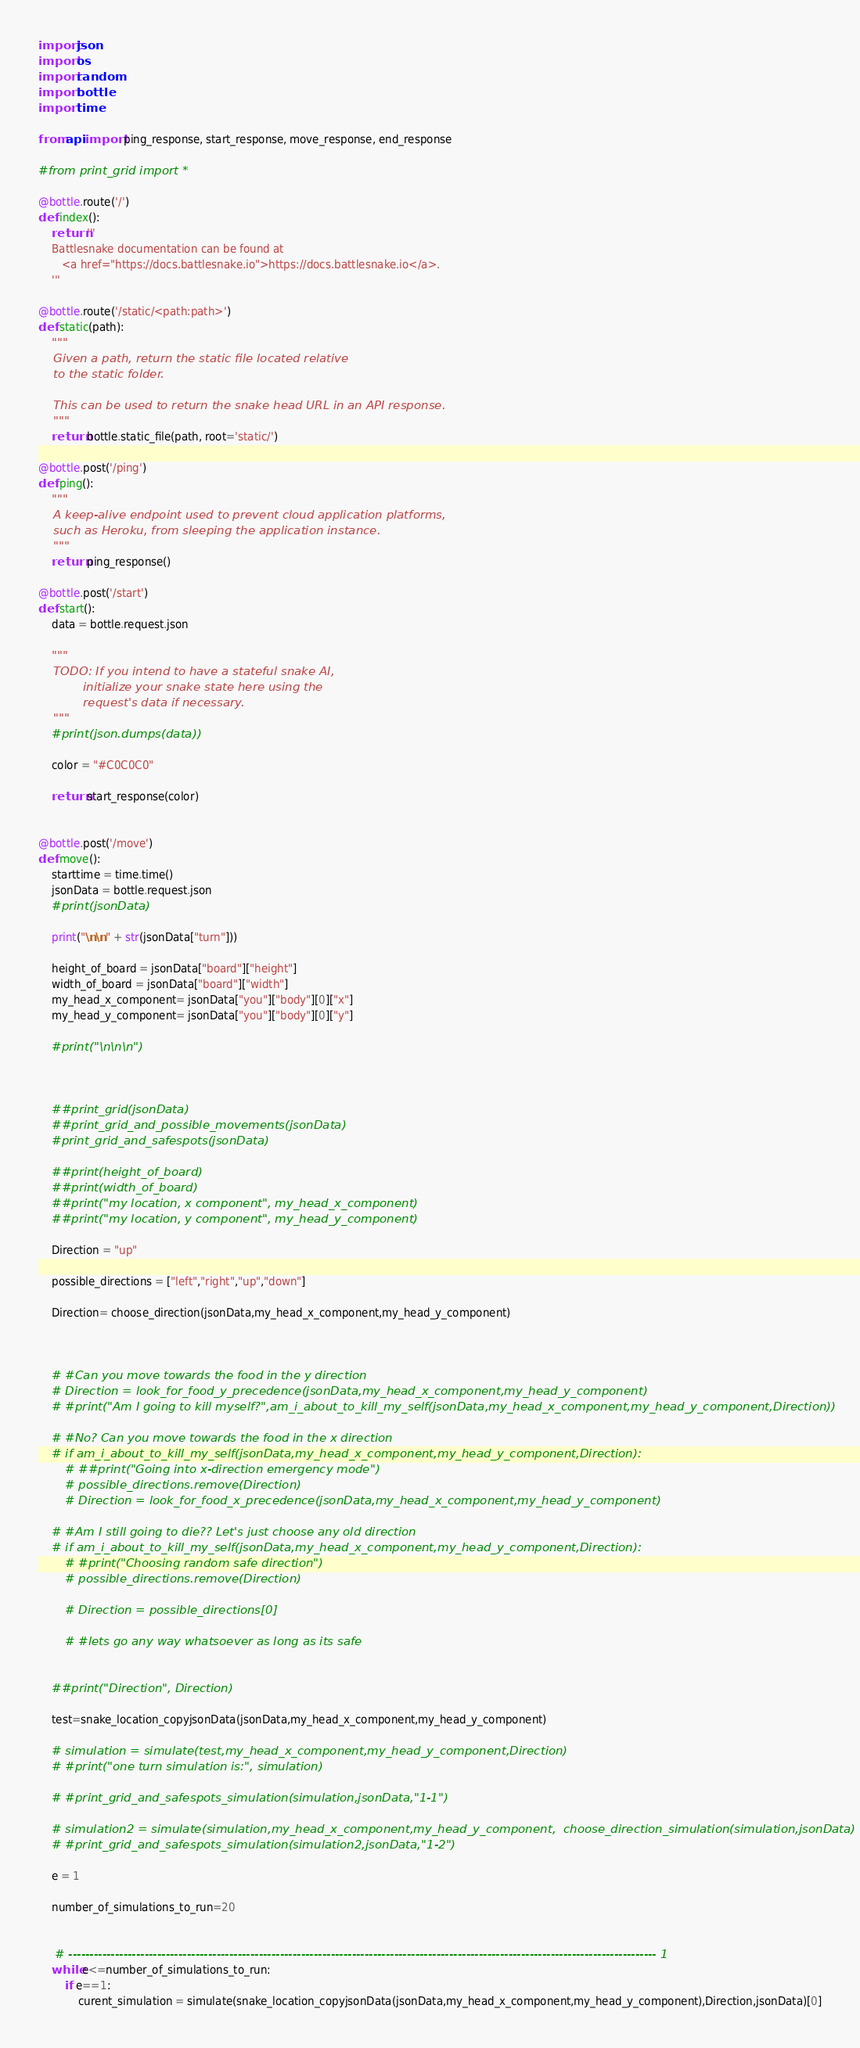<code> <loc_0><loc_0><loc_500><loc_500><_Python_>import json
import os
import random
import bottle
import time

from api import ping_response, start_response, move_response, end_response

#from print_grid import *

@bottle.route('/')
def index():
    return '''
    Battlesnake documentation can be found at
       <a href="https://docs.battlesnake.io">https://docs.battlesnake.io</a>.
    '''

@bottle.route('/static/<path:path>')
def static(path):
    """
    Given a path, return the static file located relative
    to the static folder.

    This can be used to return the snake head URL in an API response.
    """
    return bottle.static_file(path, root='static/')

@bottle.post('/ping')
def ping():
    """
    A keep-alive endpoint used to prevent cloud application platforms,
    such as Heroku, from sleeping the application instance.
    """
    return ping_response()

@bottle.post('/start')
def start():
    data = bottle.request.json

    """
    TODO: If you intend to have a stateful snake AI,
            initialize your snake state here using the
            request's data if necessary.
    """
    #print(json.dumps(data))

    color = "#C0C0C0"

    return start_response(color)


@bottle.post('/move')
def move():
    starttime = time.time()
    jsonData = bottle.request.json
    #print(jsonData)
    
    print("\n\n" + str(jsonData["turn"]))
    
    height_of_board = jsonData["board"]["height"]
    width_of_board = jsonData["board"]["width"]
    my_head_x_component= jsonData["you"]["body"][0]["x"]
    my_head_y_component= jsonData["you"]["body"][0]["y"]
    
    #print("\n\n\n")
    
    
    
    ##print_grid(jsonData)
    ##print_grid_and_possible_movements(jsonData)
    #print_grid_and_safespots(jsonData)
    
    ##print(height_of_board)
    ##print(width_of_board)
    ##print("my location, x component", my_head_x_component)
    ##print("my location, y component", my_head_y_component)
    
    Direction = "up"
    
    possible_directions = ["left","right","up","down"]
    
    Direction= choose_direction(jsonData,my_head_x_component,my_head_y_component)
    
    

    # #Can you move towards the food in the y direction
    # Direction = look_for_food_y_precedence(jsonData,my_head_x_component,my_head_y_component)
    # #print("Am I going to kill myself?",am_i_about_to_kill_my_self(jsonData,my_head_x_component,my_head_y_component,Direction))
    
    # #No? Can you move towards the food in the x direction
    # if am_i_about_to_kill_my_self(jsonData,my_head_x_component,my_head_y_component,Direction):
        # ##print("Going into x-direction emergency mode")
        # possible_directions.remove(Direction)
        # Direction = look_for_food_x_precedence(jsonData,my_head_x_component,my_head_y_component)
        
    # #Am I still going to die?? Let's just choose any old direction
    # if am_i_about_to_kill_my_self(jsonData,my_head_x_component,my_head_y_component,Direction):
        # #print("Choosing random safe direction") 
        # possible_directions.remove(Direction)
        
        # Direction = possible_directions[0]
        
        # #lets go any way whatsoever as long as its safe
        
    
    ##print("Direction", Direction)
    
    test=snake_location_copyjsonData(jsonData,my_head_x_component,my_head_y_component)
    
    # simulation = simulate(test,my_head_x_component,my_head_y_component,Direction)
    # #print("one turn simulation is:", simulation)
    
    # #print_grid_and_safespots_simulation(simulation,jsonData,"1-1")
    
    # simulation2 = simulate(simulation,my_head_x_component,my_head_y_component,  choose_direction_simulation(simulation,jsonData)  )
    # #print_grid_and_safespots_simulation(simulation2,jsonData,"1-2")
    
    e = 1
    
    number_of_simulations_to_run=20
    
    
     # ------------------------------------------------------------------------------------------------------------------------------------------- 1
    while e<=number_of_simulations_to_run:
        if e==1:
            curent_simulation = simulate(snake_location_copyjsonData(jsonData,my_head_x_component,my_head_y_component),Direction,jsonData)[0]</code> 